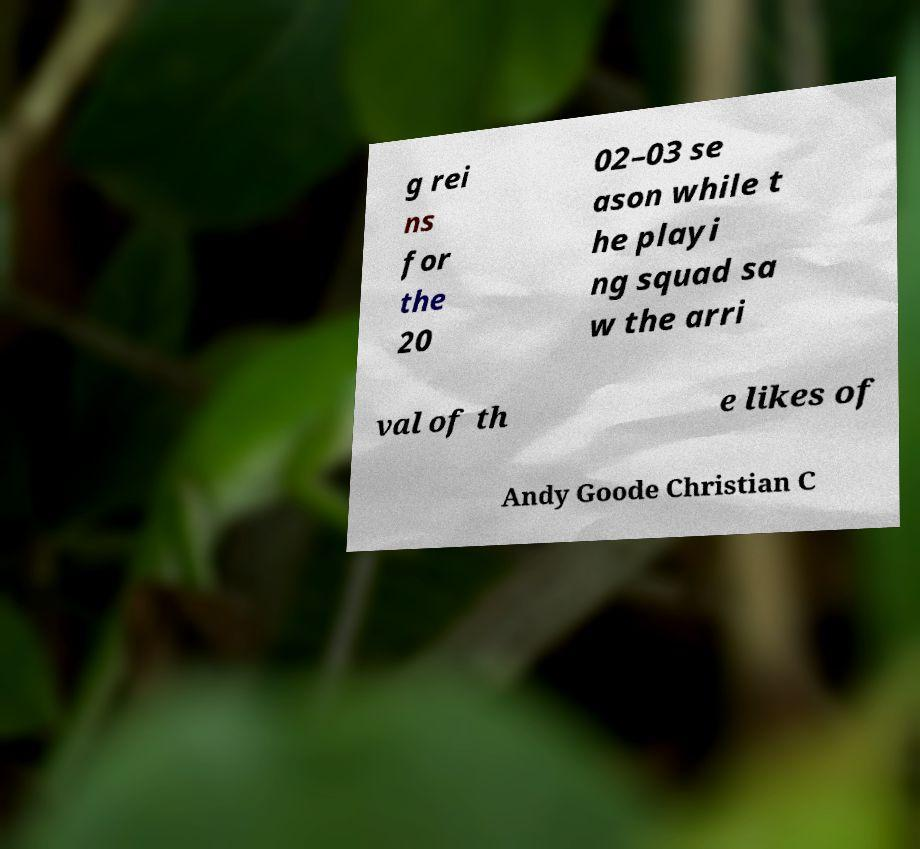I need the written content from this picture converted into text. Can you do that? g rei ns for the 20 02–03 se ason while t he playi ng squad sa w the arri val of th e likes of Andy Goode Christian C 